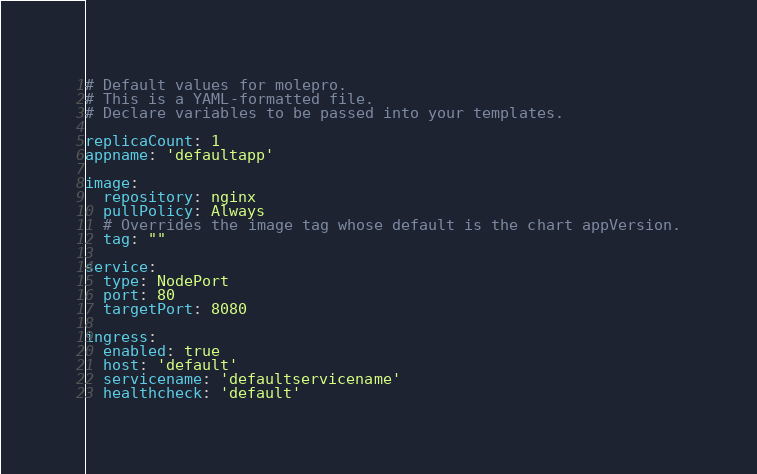Convert code to text. <code><loc_0><loc_0><loc_500><loc_500><_YAML_># Default values for molepro.
# This is a YAML-formatted file.
# Declare variables to be passed into your templates.

replicaCount: 1
appname: 'defaultapp'

image:
  repository: nginx
  pullPolicy: Always
  # Overrides the image tag whose default is the chart appVersion.
  tag: ""

service:
  type: NodePort
  port: 80
  targetPort: 8080

ingress:
  enabled: true
  host: 'default'
  servicename: 'defaultservicename'
  healthcheck: 'default'
</code> 